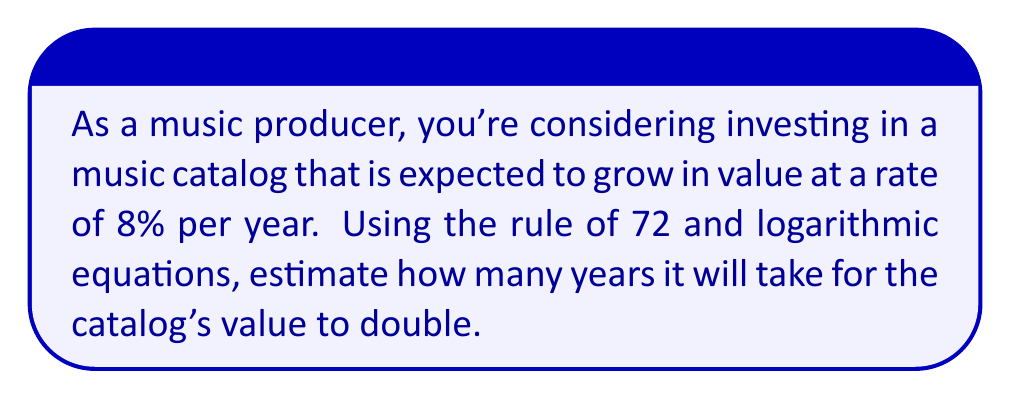Give your solution to this math problem. To solve this problem, we'll use the rule of 72 and logarithmic equations. The rule of 72 is an approximation that relates the doubling time of an investment to its growth rate.

1) The rule of 72 states that:
   $$ 72 \approx r \times t $$
   where $r$ is the growth rate (in percent) and $t$ is the time to double (in years).

2) We're given that $r = 8\%$. Let's solve for $t$:
   $$ t \approx \frac{72}{r} = \frac{72}{8} = 9 \text{ years} $$

3) This is an approximation. For a more accurate result, we can use the exact formula:
   $$ 2 = (1 + \frac{r}{100})^t $$

4) Taking the natural logarithm of both sides:
   $$ \ln(2) = t \times \ln(1 + \frac{r}{100}) $$

5) Solving for $t$:
   $$ t = \frac{\ln(2)}{\ln(1 + \frac{r}{100})} = \frac{\ln(2)}{\ln(1.08)} \approx 9.006 \text{ years} $$

The exact calculation confirms that our estimate using the rule of 72 was very close.
Answer: It will take approximately 9 years for the music catalog's value to double. 